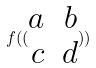<formula> <loc_0><loc_0><loc_500><loc_500>f ( ( \begin{matrix} a & b \\ c & d \end{matrix} ) )</formula> 